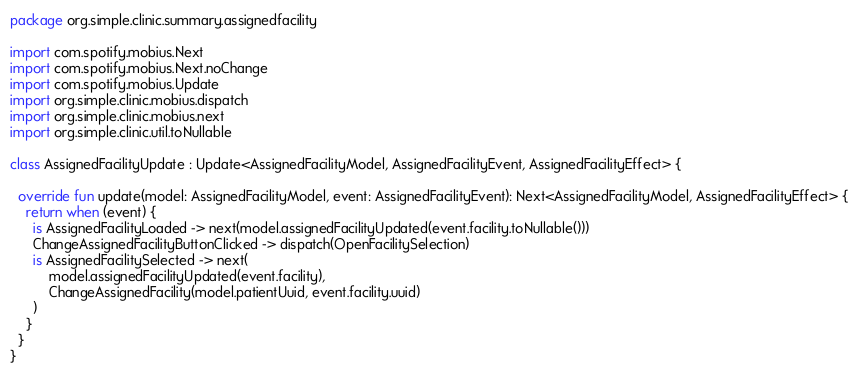<code> <loc_0><loc_0><loc_500><loc_500><_Kotlin_>package org.simple.clinic.summary.assignedfacility

import com.spotify.mobius.Next
import com.spotify.mobius.Next.noChange
import com.spotify.mobius.Update
import org.simple.clinic.mobius.dispatch
import org.simple.clinic.mobius.next
import org.simple.clinic.util.toNullable

class AssignedFacilityUpdate : Update<AssignedFacilityModel, AssignedFacilityEvent, AssignedFacilityEffect> {

  override fun update(model: AssignedFacilityModel, event: AssignedFacilityEvent): Next<AssignedFacilityModel, AssignedFacilityEffect> {
    return when (event) {
      is AssignedFacilityLoaded -> next(model.assignedFacilityUpdated(event.facility.toNullable()))
      ChangeAssignedFacilityButtonClicked -> dispatch(OpenFacilitySelection)
      is AssignedFacilitySelected -> next(
          model.assignedFacilityUpdated(event.facility),
          ChangeAssignedFacility(model.patientUuid, event.facility.uuid)
      )
    }
  }
}
</code> 